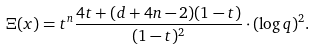<formula> <loc_0><loc_0><loc_500><loc_500>& \Xi ( x ) = t ^ { n } \frac { 4 t + ( d + 4 n - 2 ) ( 1 - t ) } { ( 1 - t ) ^ { 2 } } \cdot ( \log q ) ^ { 2 } .</formula> 